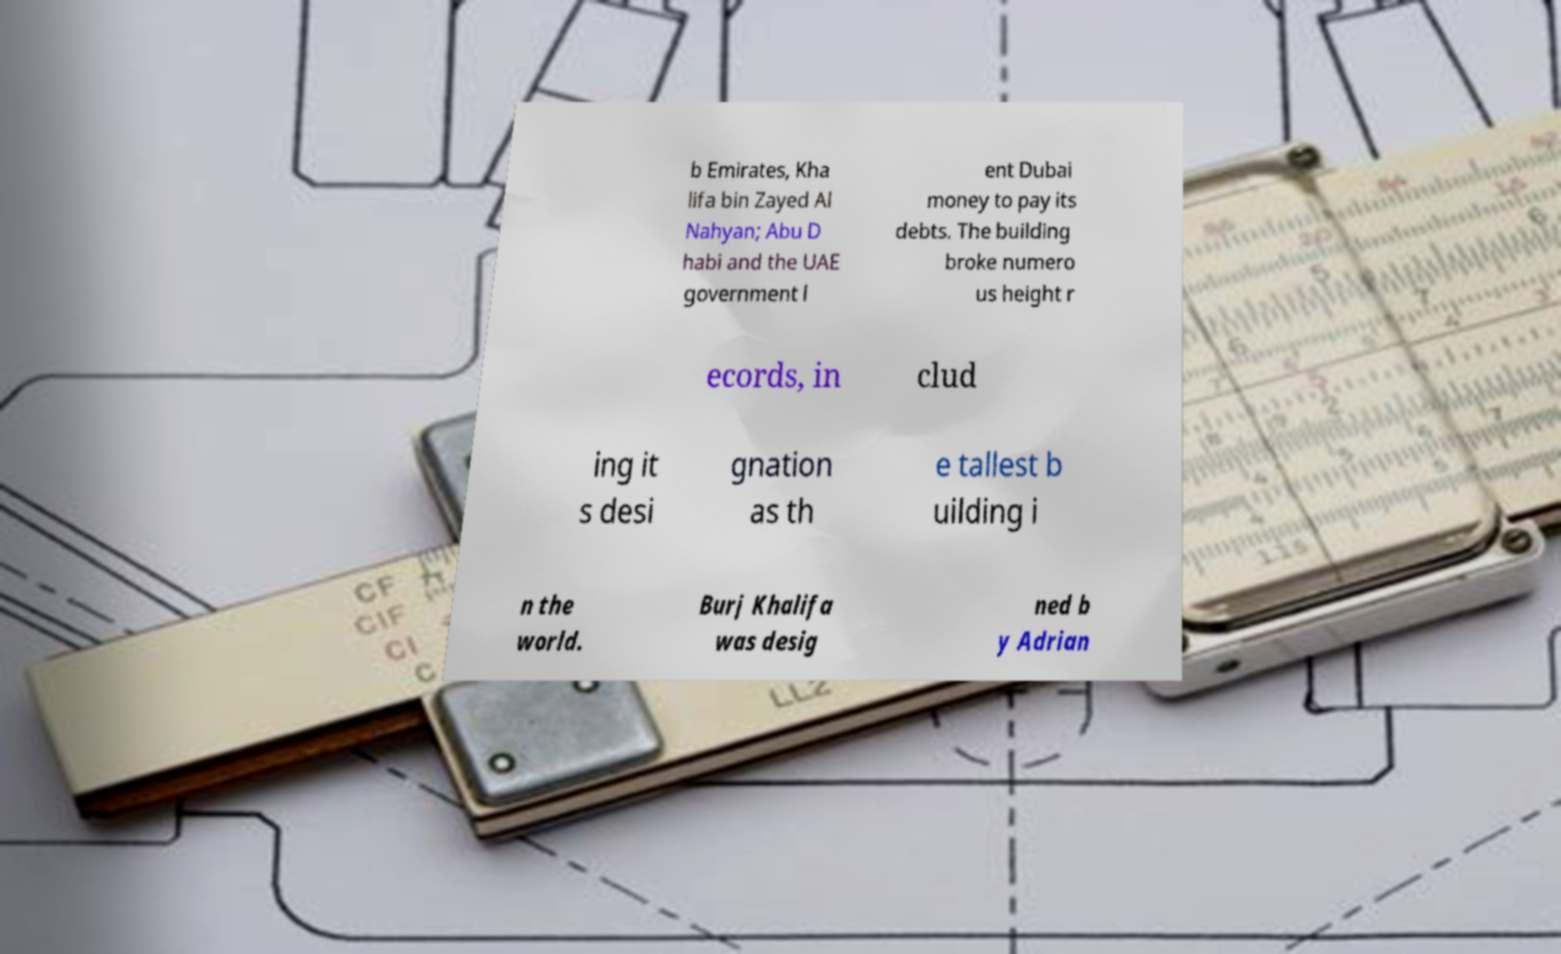There's text embedded in this image that I need extracted. Can you transcribe it verbatim? b Emirates, Kha lifa bin Zayed Al Nahyan; Abu D habi and the UAE government l ent Dubai money to pay its debts. The building broke numero us height r ecords, in clud ing it s desi gnation as th e tallest b uilding i n the world. Burj Khalifa was desig ned b y Adrian 